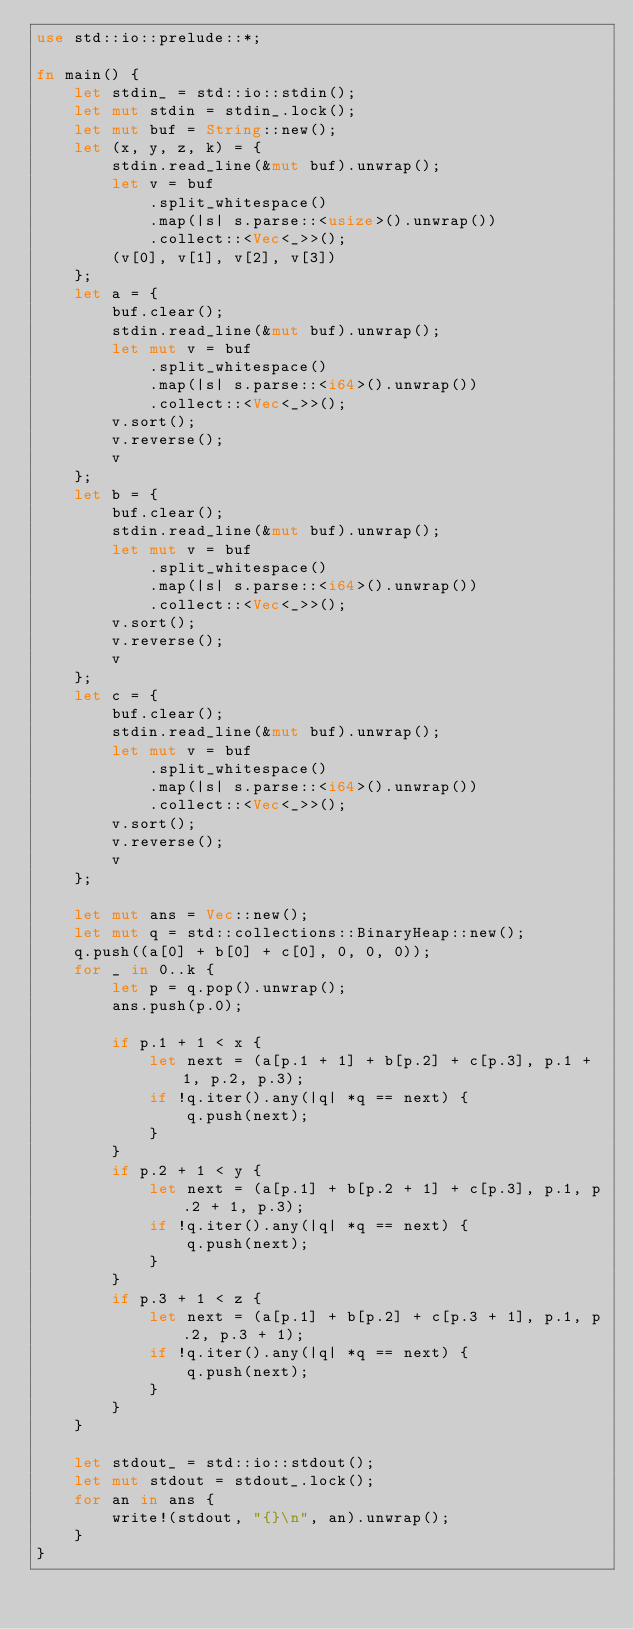<code> <loc_0><loc_0><loc_500><loc_500><_Rust_>use std::io::prelude::*;

fn main() {
    let stdin_ = std::io::stdin();
    let mut stdin = stdin_.lock();
    let mut buf = String::new();
    let (x, y, z, k) = {
        stdin.read_line(&mut buf).unwrap();
        let v = buf
            .split_whitespace()
            .map(|s| s.parse::<usize>().unwrap())
            .collect::<Vec<_>>();
        (v[0], v[1], v[2], v[3])
    };
    let a = {
        buf.clear();
        stdin.read_line(&mut buf).unwrap();
        let mut v = buf
            .split_whitespace()
            .map(|s| s.parse::<i64>().unwrap())
            .collect::<Vec<_>>();
        v.sort();
        v.reverse();
        v
    };
    let b = {
        buf.clear();
        stdin.read_line(&mut buf).unwrap();
        let mut v = buf
            .split_whitespace()
            .map(|s| s.parse::<i64>().unwrap())
            .collect::<Vec<_>>();
        v.sort();
        v.reverse();
        v
    };
    let c = {
        buf.clear();
        stdin.read_line(&mut buf).unwrap();
        let mut v = buf
            .split_whitespace()
            .map(|s| s.parse::<i64>().unwrap())
            .collect::<Vec<_>>();
        v.sort();
        v.reverse();
        v
    };

    let mut ans = Vec::new();
    let mut q = std::collections::BinaryHeap::new();
    q.push((a[0] + b[0] + c[0], 0, 0, 0));
    for _ in 0..k {
        let p = q.pop().unwrap();
        ans.push(p.0);

        if p.1 + 1 < x {
            let next = (a[p.1 + 1] + b[p.2] + c[p.3], p.1 + 1, p.2, p.3);
            if !q.iter().any(|q| *q == next) {
                q.push(next);
            }
        }
        if p.2 + 1 < y {
            let next = (a[p.1] + b[p.2 + 1] + c[p.3], p.1, p.2 + 1, p.3);
            if !q.iter().any(|q| *q == next) {
                q.push(next);
            }
        }
        if p.3 + 1 < z {
            let next = (a[p.1] + b[p.2] + c[p.3 + 1], p.1, p.2, p.3 + 1);
            if !q.iter().any(|q| *q == next) {
                q.push(next);
            }
        }
    }

    let stdout_ = std::io::stdout();
    let mut stdout = stdout_.lock();
    for an in ans {
        write!(stdout, "{}\n", an).unwrap();
    }
}
</code> 